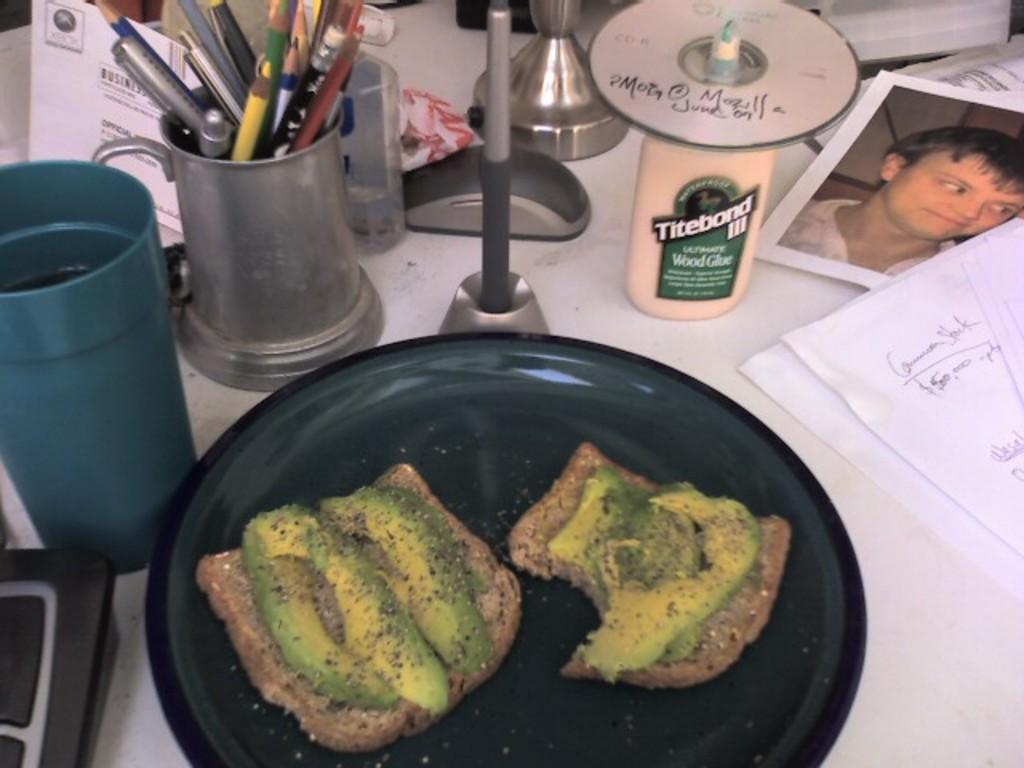Describe this image in one or two sentences. In the foreground of this picture we can see a table on the top of which a photograph, plate of food, pencils, pens, bottle, papers and some other items are placed and we can see the text on the papers. 